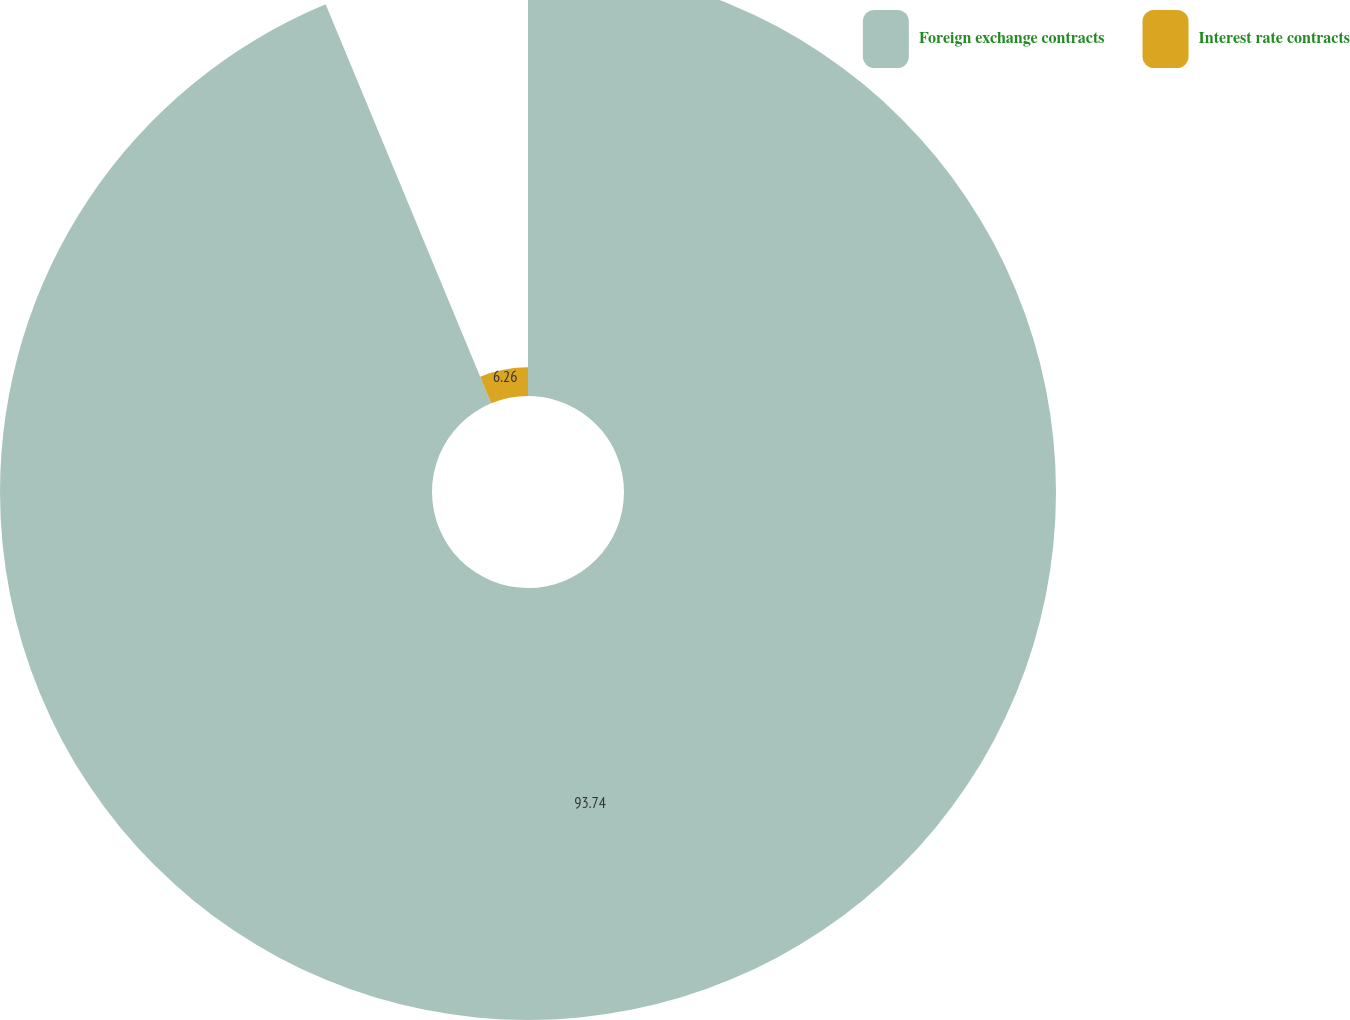Convert chart to OTSL. <chart><loc_0><loc_0><loc_500><loc_500><pie_chart><fcel>Foreign exchange contracts<fcel>Interest rate contracts<nl><fcel>93.74%<fcel>6.26%<nl></chart> 